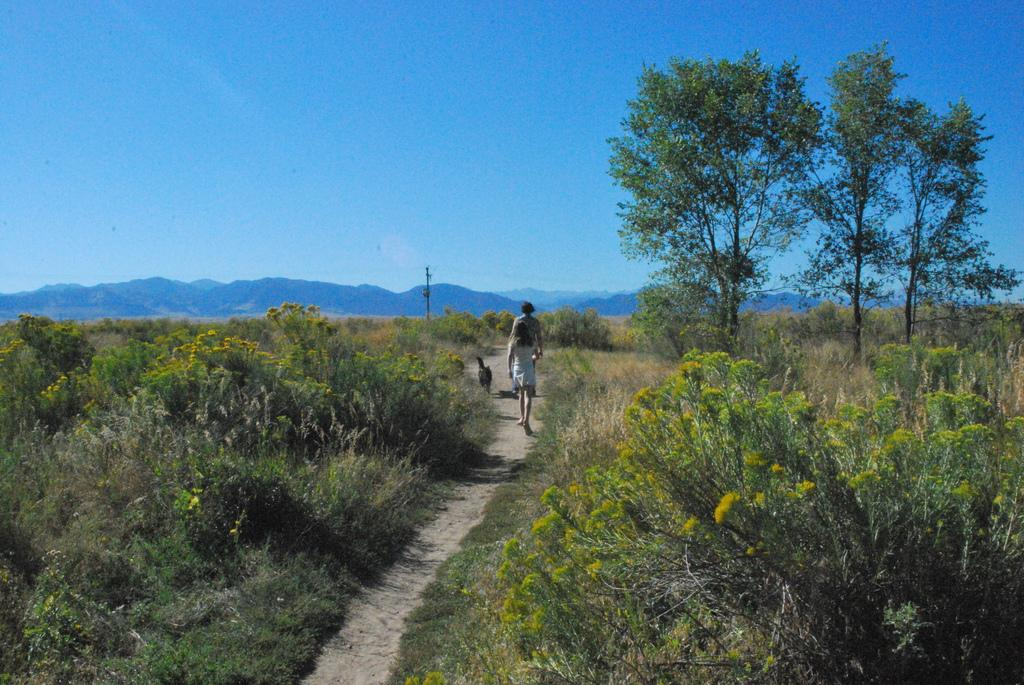What can be seen in the background of the image? There is a sky and hills visible in the background of the image. What type of vegetation is present in the image? There are trees and plants in the image. What structure can be seen in the image? There is a pole in the image. What is the animal visible in the image? The animal in the image is not specified, but it is present. What are the people in the image doing? People are walking in the image. What type of seeds can be seen growing on the trees in the image? There is no mention of seeds in the image, and the type of trees is not specified. What kind of skin is visible on the people walking in the image? There is no information about the skin of the people walking in the image, and it is not relevant to the description of the image. 